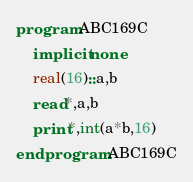<code> <loc_0><loc_0><loc_500><loc_500><_FORTRAN_>program ABC169C
    implicit none
    real(16)::a,b
    read*,a,b
    print*,int(a*b,16)
end program ABC169C</code> 